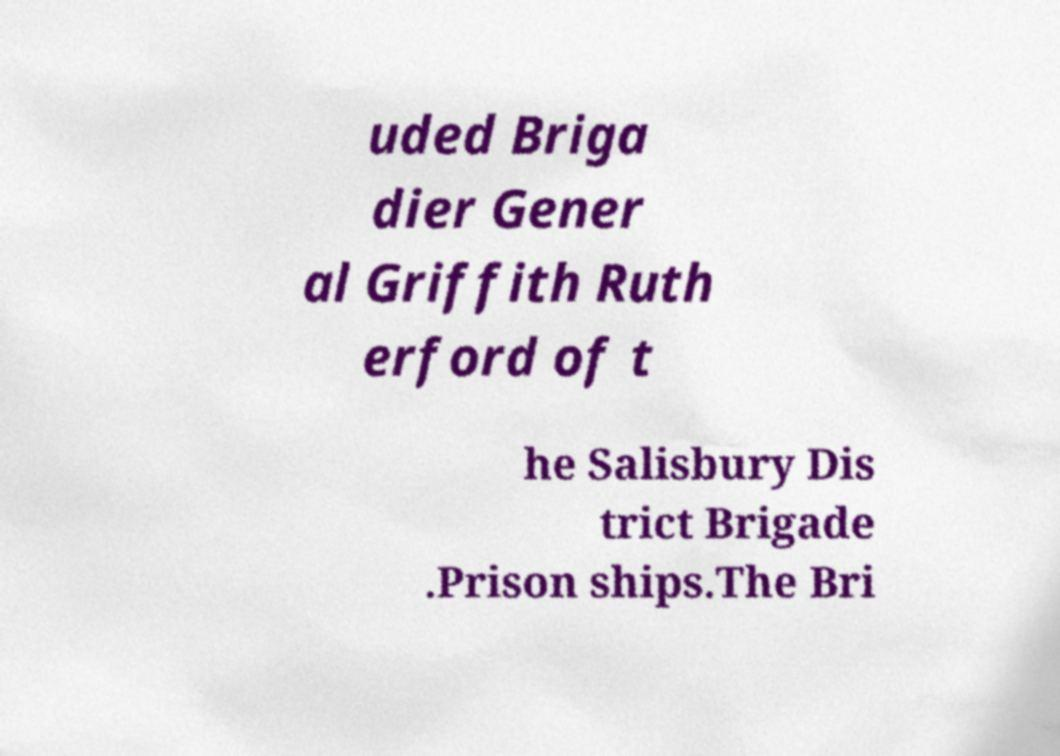Can you accurately transcribe the text from the provided image for me? uded Briga dier Gener al Griffith Ruth erford of t he Salisbury Dis trict Brigade .Prison ships.The Bri 